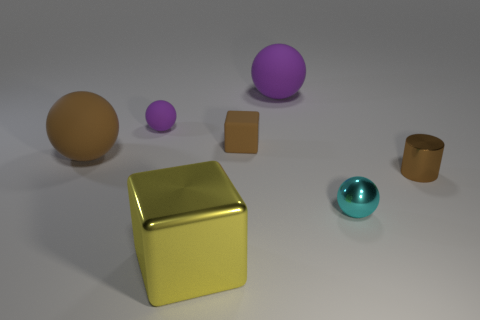Subtract 1 spheres. How many spheres are left? 3 Subtract all cyan spheres. Subtract all yellow cylinders. How many spheres are left? 3 Add 2 big brown matte spheres. How many objects exist? 9 Subtract all spheres. How many objects are left? 3 Subtract 0 red cylinders. How many objects are left? 7 Subtract all big purple things. Subtract all big cubes. How many objects are left? 5 Add 1 big rubber things. How many big rubber things are left? 3 Add 7 tiny matte spheres. How many tiny matte spheres exist? 8 